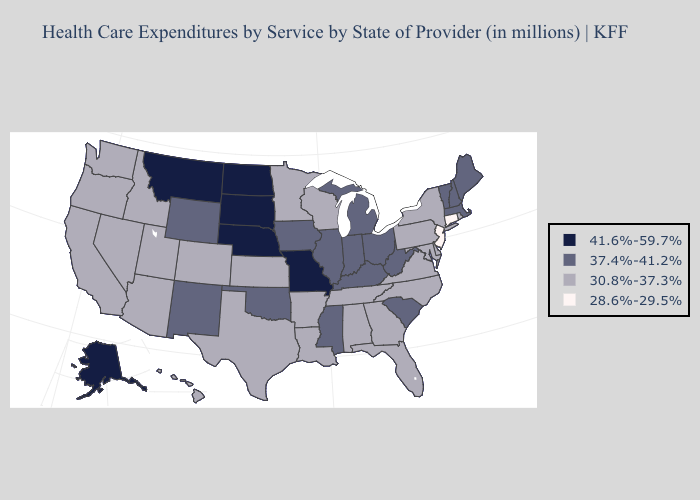Which states have the lowest value in the West?
Answer briefly. Arizona, California, Colorado, Hawaii, Idaho, Nevada, Oregon, Utah, Washington. Name the states that have a value in the range 37.4%-41.2%?
Concise answer only. Illinois, Indiana, Iowa, Kentucky, Maine, Massachusetts, Michigan, Mississippi, New Hampshire, New Mexico, Ohio, Oklahoma, South Carolina, Vermont, West Virginia, Wyoming. Name the states that have a value in the range 41.6%-59.7%?
Quick response, please. Alaska, Missouri, Montana, Nebraska, North Dakota, South Dakota. Which states have the lowest value in the USA?
Keep it brief. Connecticut, New Jersey. Name the states that have a value in the range 41.6%-59.7%?
Answer briefly. Alaska, Missouri, Montana, Nebraska, North Dakota, South Dakota. Does the first symbol in the legend represent the smallest category?
Concise answer only. No. What is the value of New York?
Short answer required. 30.8%-37.3%. What is the lowest value in the USA?
Write a very short answer. 28.6%-29.5%. Name the states that have a value in the range 30.8%-37.3%?
Answer briefly. Alabama, Arizona, Arkansas, California, Colorado, Delaware, Florida, Georgia, Hawaii, Idaho, Kansas, Louisiana, Maryland, Minnesota, Nevada, New York, North Carolina, Oregon, Pennsylvania, Rhode Island, Tennessee, Texas, Utah, Virginia, Washington, Wisconsin. What is the value of North Dakota?
Short answer required. 41.6%-59.7%. Does Mississippi have the highest value in the South?
Write a very short answer. Yes. What is the lowest value in states that border West Virginia?
Write a very short answer. 30.8%-37.3%. Which states have the lowest value in the USA?
Quick response, please. Connecticut, New Jersey. Does Kentucky have the highest value in the USA?
Give a very brief answer. No. 